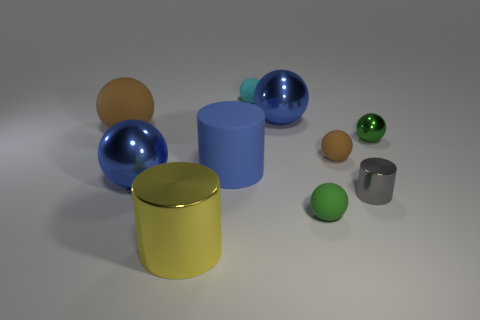Subtract all cyan spheres. How many spheres are left? 6 Subtract all large matte spheres. How many spheres are left? 6 Subtract all blue balls. Subtract all green cubes. How many balls are left? 5 Subtract all cylinders. How many objects are left? 7 Add 3 small brown rubber spheres. How many small brown rubber spheres are left? 4 Add 1 yellow cylinders. How many yellow cylinders exist? 2 Subtract 0 brown cylinders. How many objects are left? 10 Subtract all blue metal balls. Subtract all big blue metallic things. How many objects are left? 6 